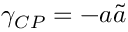Convert formula to latex. <formula><loc_0><loc_0><loc_500><loc_500>\gamma _ { C P } = - a \tilde { a }</formula> 